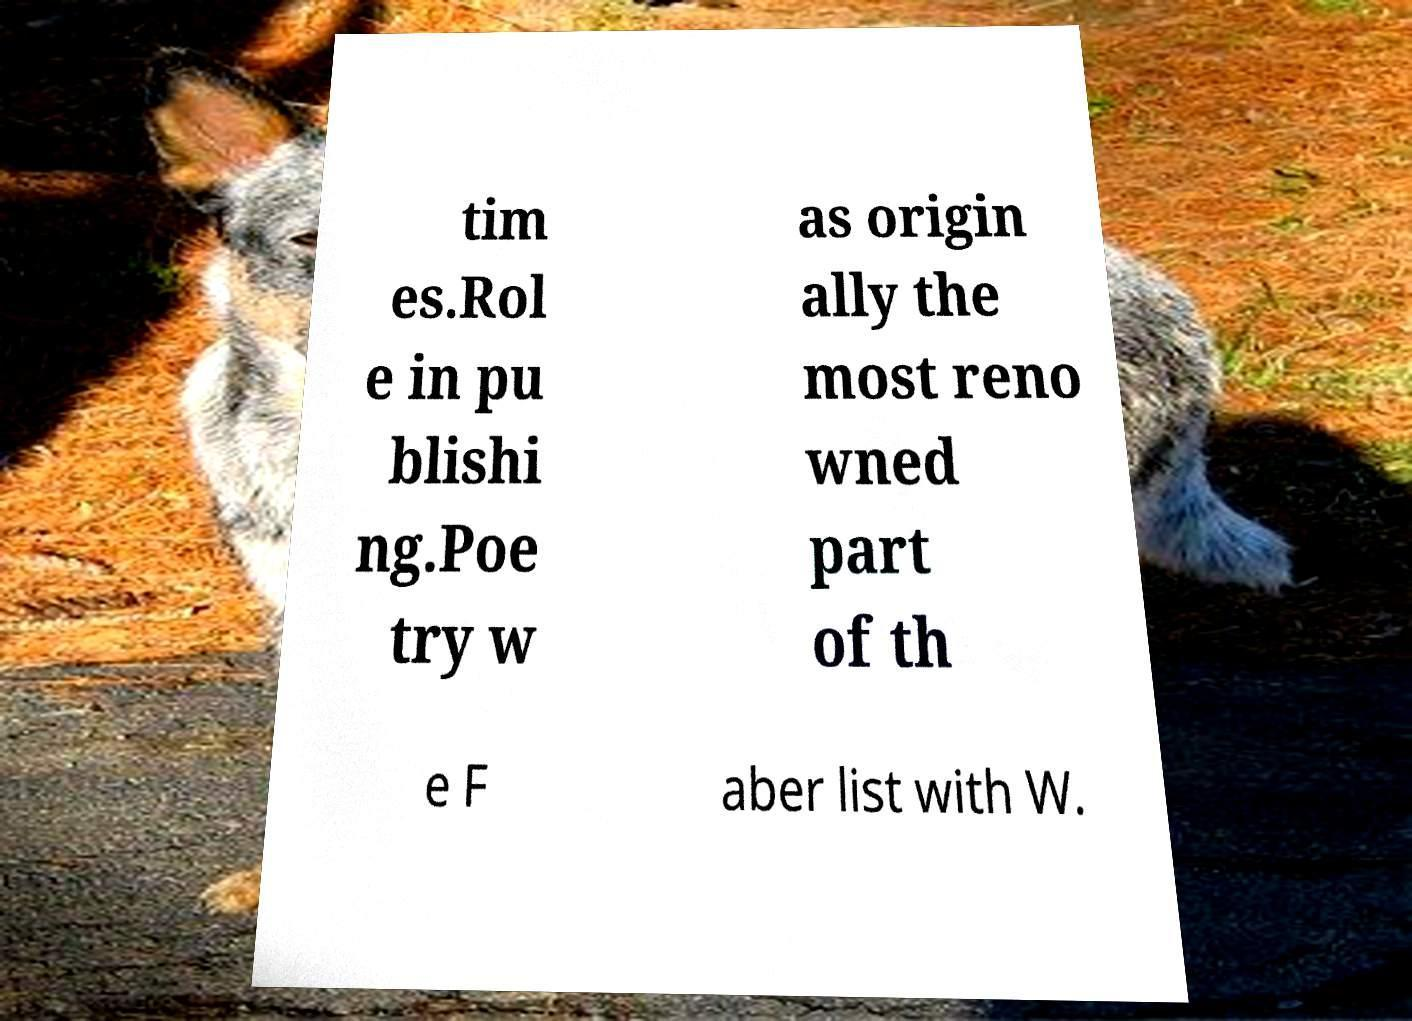I need the written content from this picture converted into text. Can you do that? tim es.Rol e in pu blishi ng.Poe try w as origin ally the most reno wned part of th e F aber list with W. 